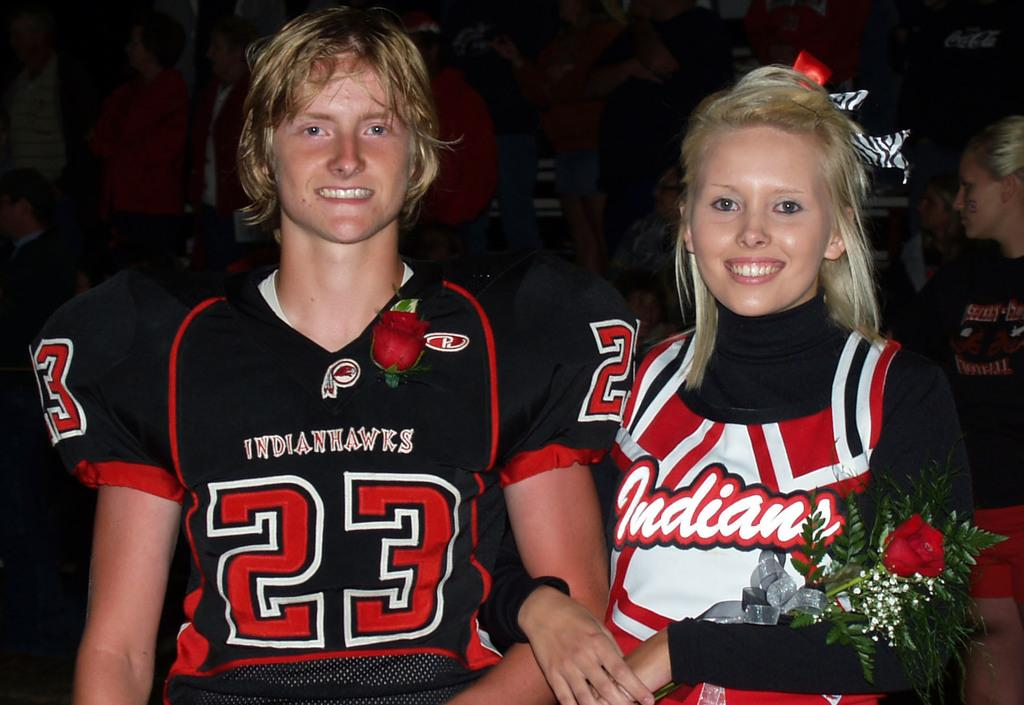<image>
Write a terse but informative summary of the picture. A man and a women wearing an Indians team outfit. 